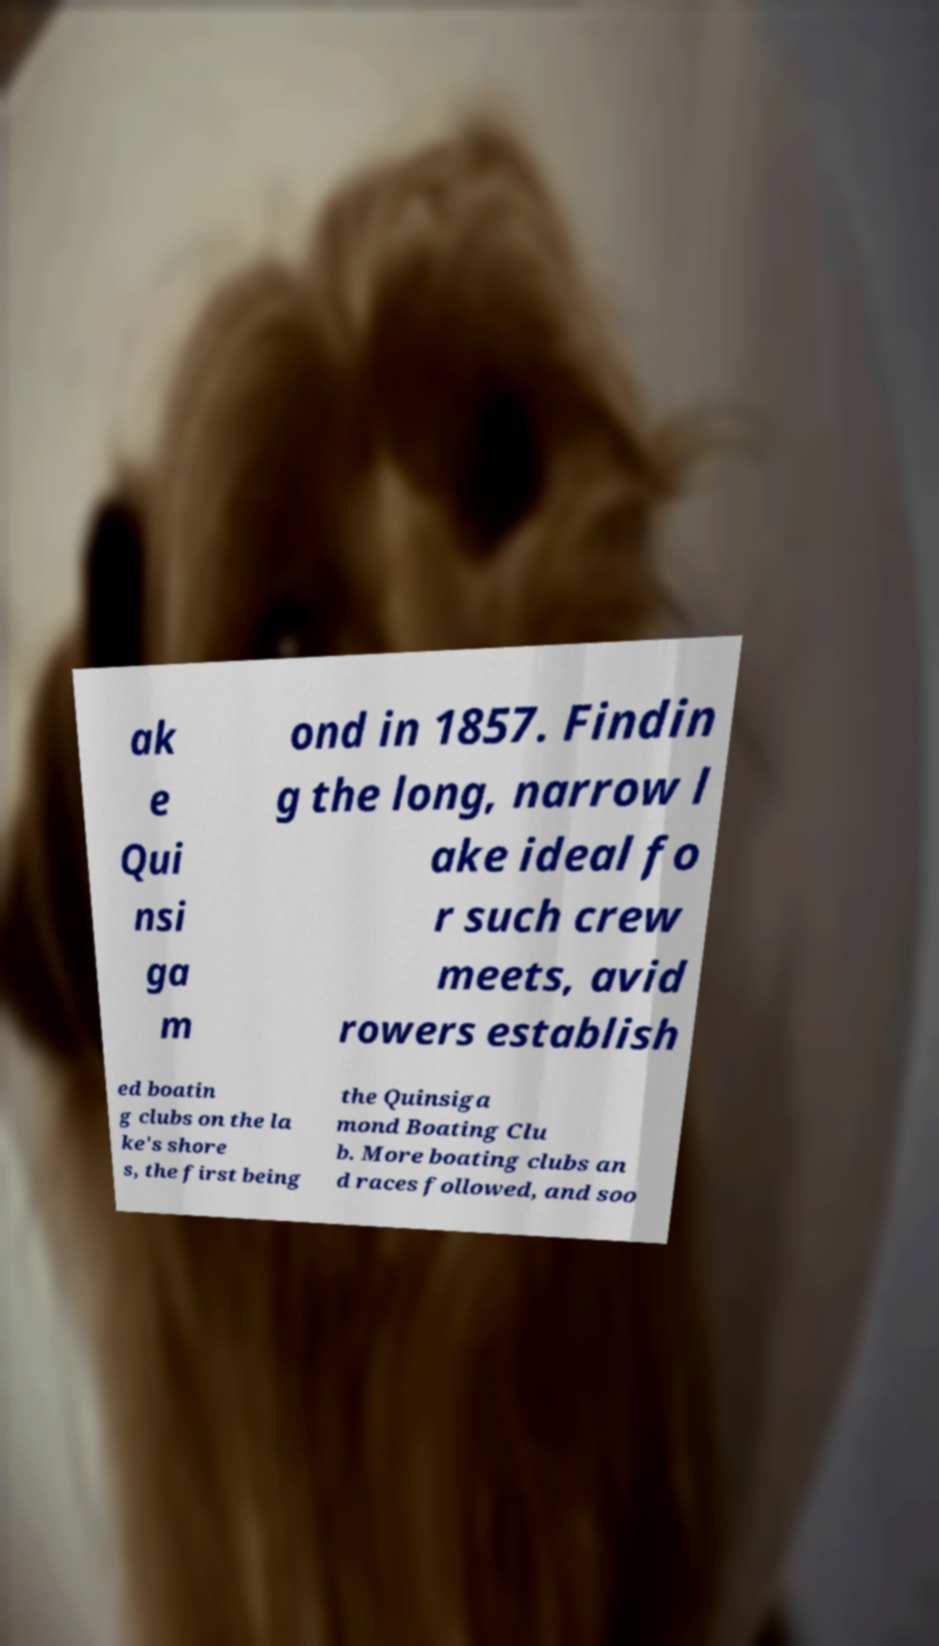Can you read and provide the text displayed in the image?This photo seems to have some interesting text. Can you extract and type it out for me? ak e Qui nsi ga m ond in 1857. Findin g the long, narrow l ake ideal fo r such crew meets, avid rowers establish ed boatin g clubs on the la ke's shore s, the first being the Quinsiga mond Boating Clu b. More boating clubs an d races followed, and soo 